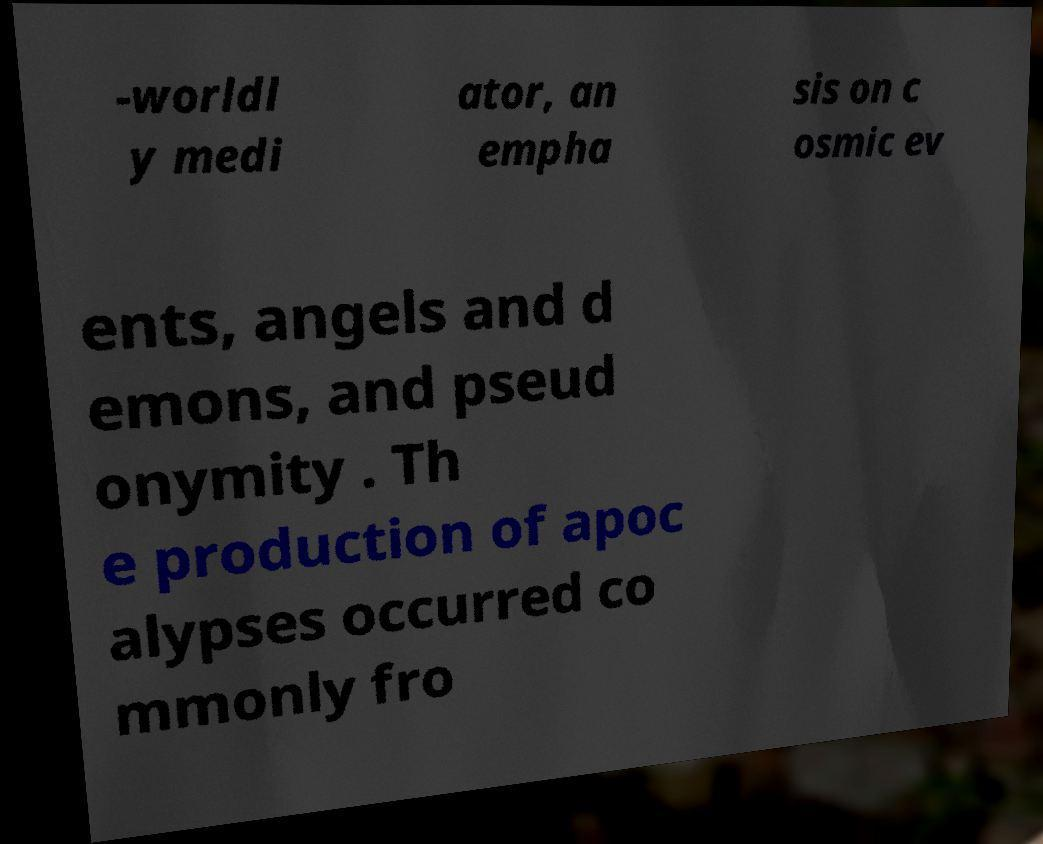Could you extract and type out the text from this image? -worldl y medi ator, an empha sis on c osmic ev ents, angels and d emons, and pseud onymity . Th e production of apoc alypses occurred co mmonly fro 